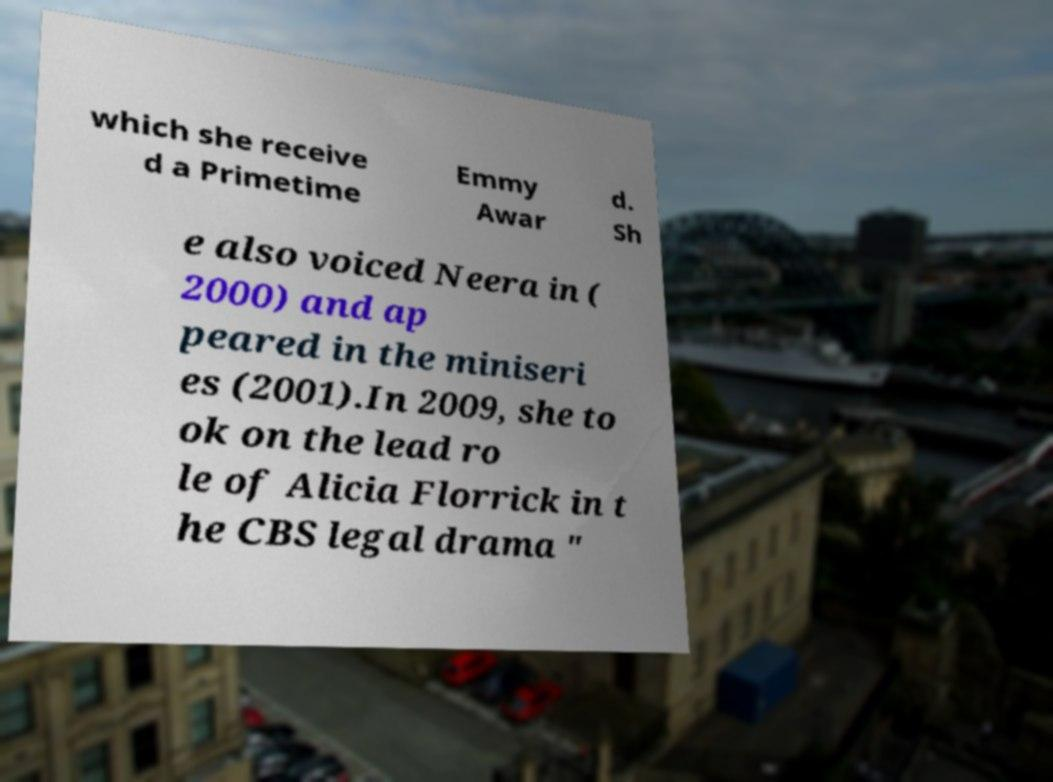Can you accurately transcribe the text from the provided image for me? which she receive d a Primetime Emmy Awar d. Sh e also voiced Neera in ( 2000) and ap peared in the miniseri es (2001).In 2009, she to ok on the lead ro le of Alicia Florrick in t he CBS legal drama " 